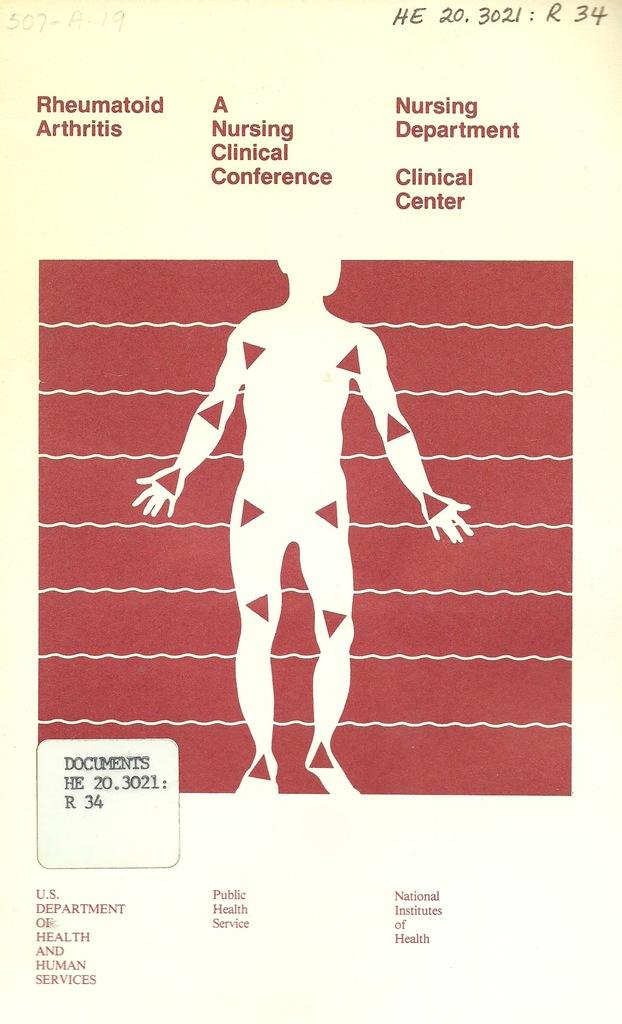What type of image is being described? The image is a drawing. What is shown in the drawing? There is a depiction of a person in the drawing. Are there any words or letters in the image? Yes, there is text at the top of the image and text at the bottom of the image. What type of cloth is being gripped by the person's foot in the image? There is no cloth or foot present in the image; it is a drawing of a person with text at the top and bottom. 